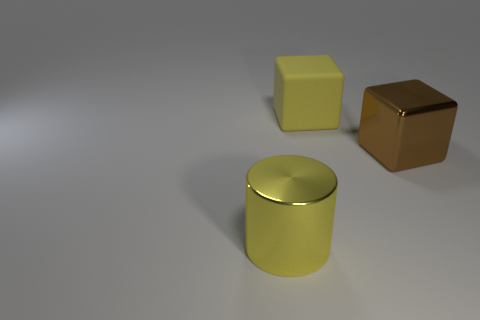Are there any indications in the image about the possible use or function of these objects? While the image itself does not provide explicit clues about use or function, the objects' basic geometric shapes - a cube and a cylinder - are reminiscent of common household items. The cube could mimic a storage box, while the cylindrical container might be used as a decorative piece or a vessel. However, without additional context, their exact uses remain speculative. 